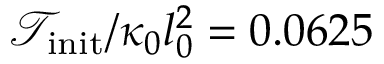Convert formula to latex. <formula><loc_0><loc_0><loc_500><loc_500>{ \mathcal { T } } _ { i n i t } / \kappa _ { 0 } l _ { 0 } ^ { 2 } = 0 . 0 6 2 5</formula> 